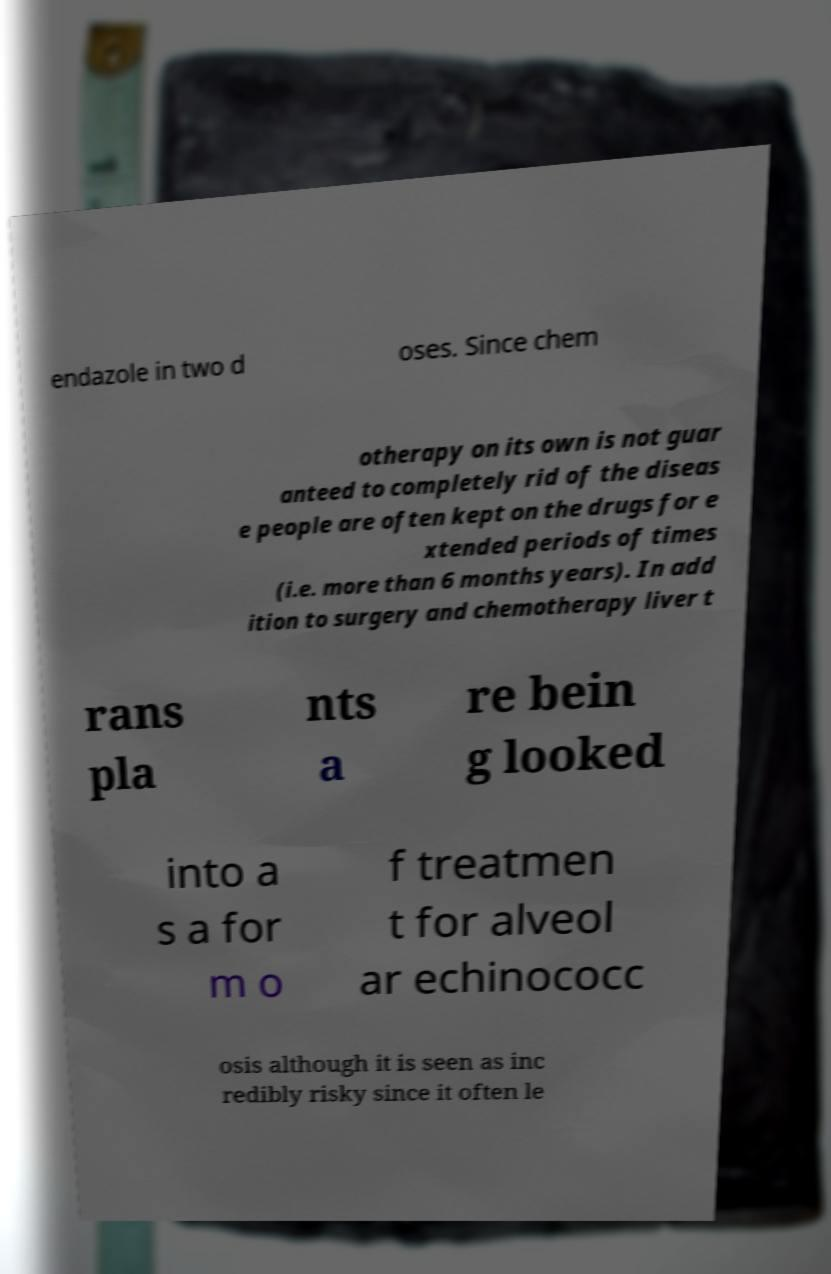Could you assist in decoding the text presented in this image and type it out clearly? endazole in two d oses. Since chem otherapy on its own is not guar anteed to completely rid of the diseas e people are often kept on the drugs for e xtended periods of times (i.e. more than 6 months years). In add ition to surgery and chemotherapy liver t rans pla nts a re bein g looked into a s a for m o f treatmen t for alveol ar echinococc osis although it is seen as inc redibly risky since it often le 